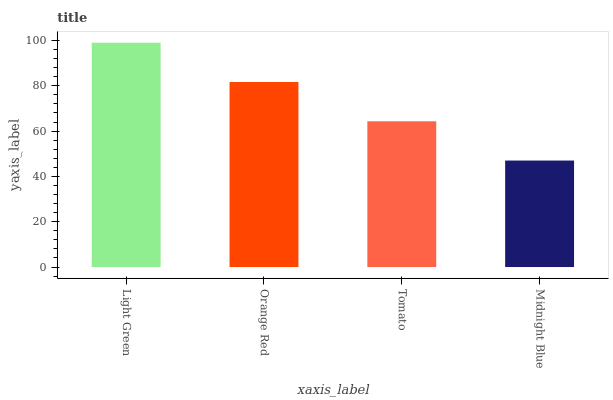Is Orange Red the minimum?
Answer yes or no. No. Is Orange Red the maximum?
Answer yes or no. No. Is Light Green greater than Orange Red?
Answer yes or no. Yes. Is Orange Red less than Light Green?
Answer yes or no. Yes. Is Orange Red greater than Light Green?
Answer yes or no. No. Is Light Green less than Orange Red?
Answer yes or no. No. Is Orange Red the high median?
Answer yes or no. Yes. Is Tomato the low median?
Answer yes or no. Yes. Is Light Green the high median?
Answer yes or no. No. Is Light Green the low median?
Answer yes or no. No. 